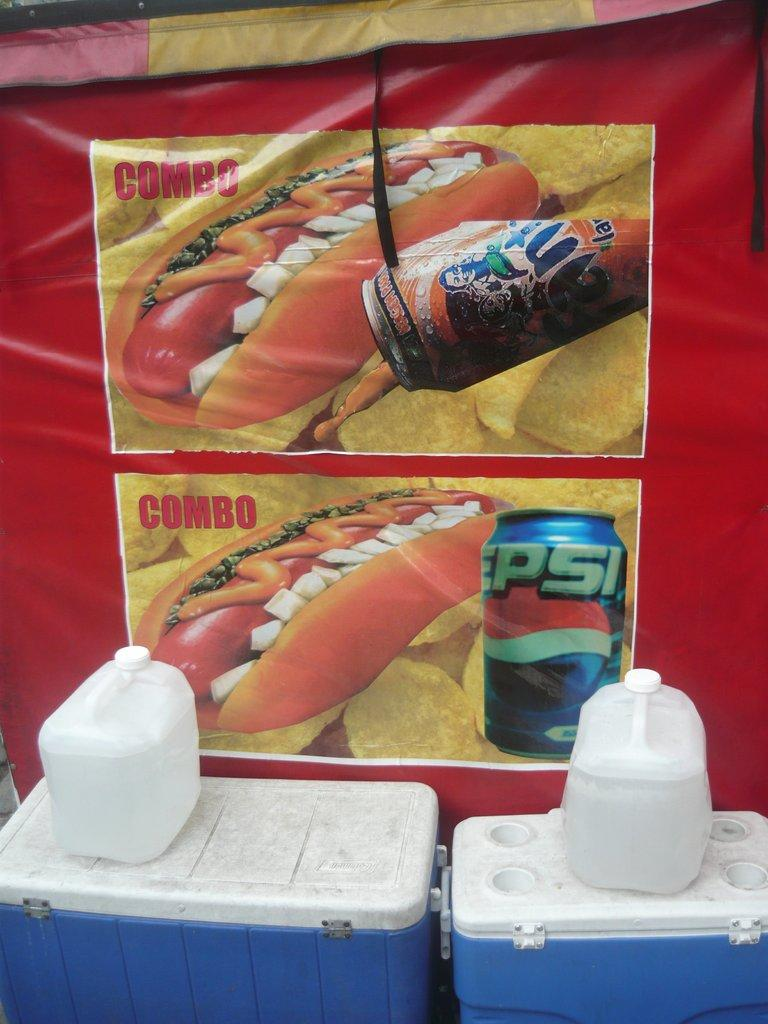What object is present in the image that can hold items? There is a container in the image that can hold items. What colors are visible on the container? The container is blue and white in color. What type of items are on the container? There are fuel bottles on the container. Is there any additional signage or information in the image? Yes, there is a banner in the image. What type of bait is being used to attract fish in the image? There is no indication of fish or bait in the image; it features a container with fuel bottles and a banner. How does the pollution affect the environment in the image? There is no mention of pollution in the image; it only shows a container, fuel bottles, and a banner. 